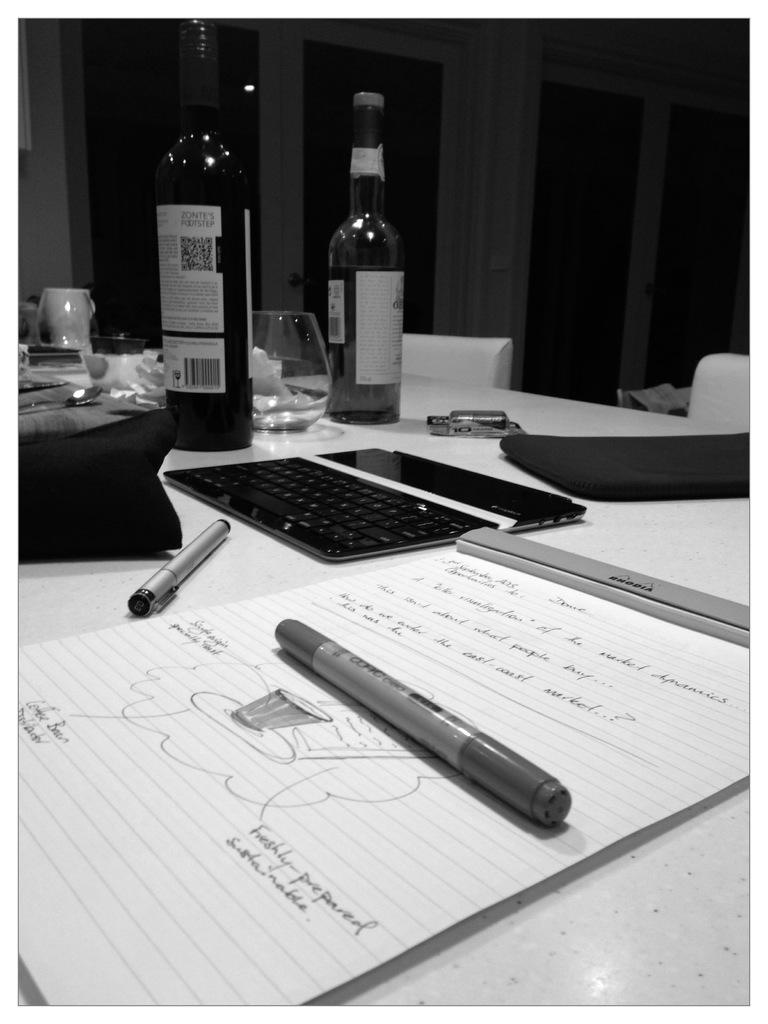What writing instruments are on the table in the image? There are pens on the table. What else can be seen on the table besides pens? There is a book, glasses, bottles of wine, and a keyboard on the table. What type of seating is visible behind the table? There are chairs behind the table. What architectural feature is present behind the table? There are glass doors behind the table. Where is the basin located in the image? There is no basin present in the image. What type of education can be seen in the image? There is no educational material or activity depicted in the image. 